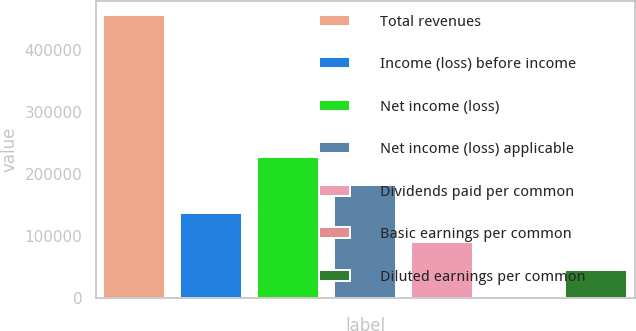Convert chart. <chart><loc_0><loc_0><loc_500><loc_500><bar_chart><fcel>Total revenues<fcel>Income (loss) before income<fcel>Net income (loss)<fcel>Net income (loss) applicable<fcel>Dividends paid per common<fcel>Basic earnings per common<fcel>Diluted earnings per common<nl><fcel>456022<fcel>136807<fcel>228011<fcel>182409<fcel>91204.6<fcel>0.21<fcel>45602.4<nl></chart> 